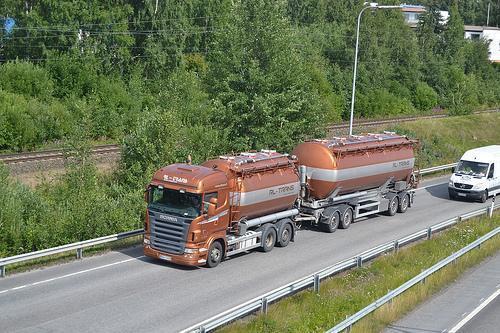How many vehicles are on the train tracks?
Give a very brief answer. 0. 